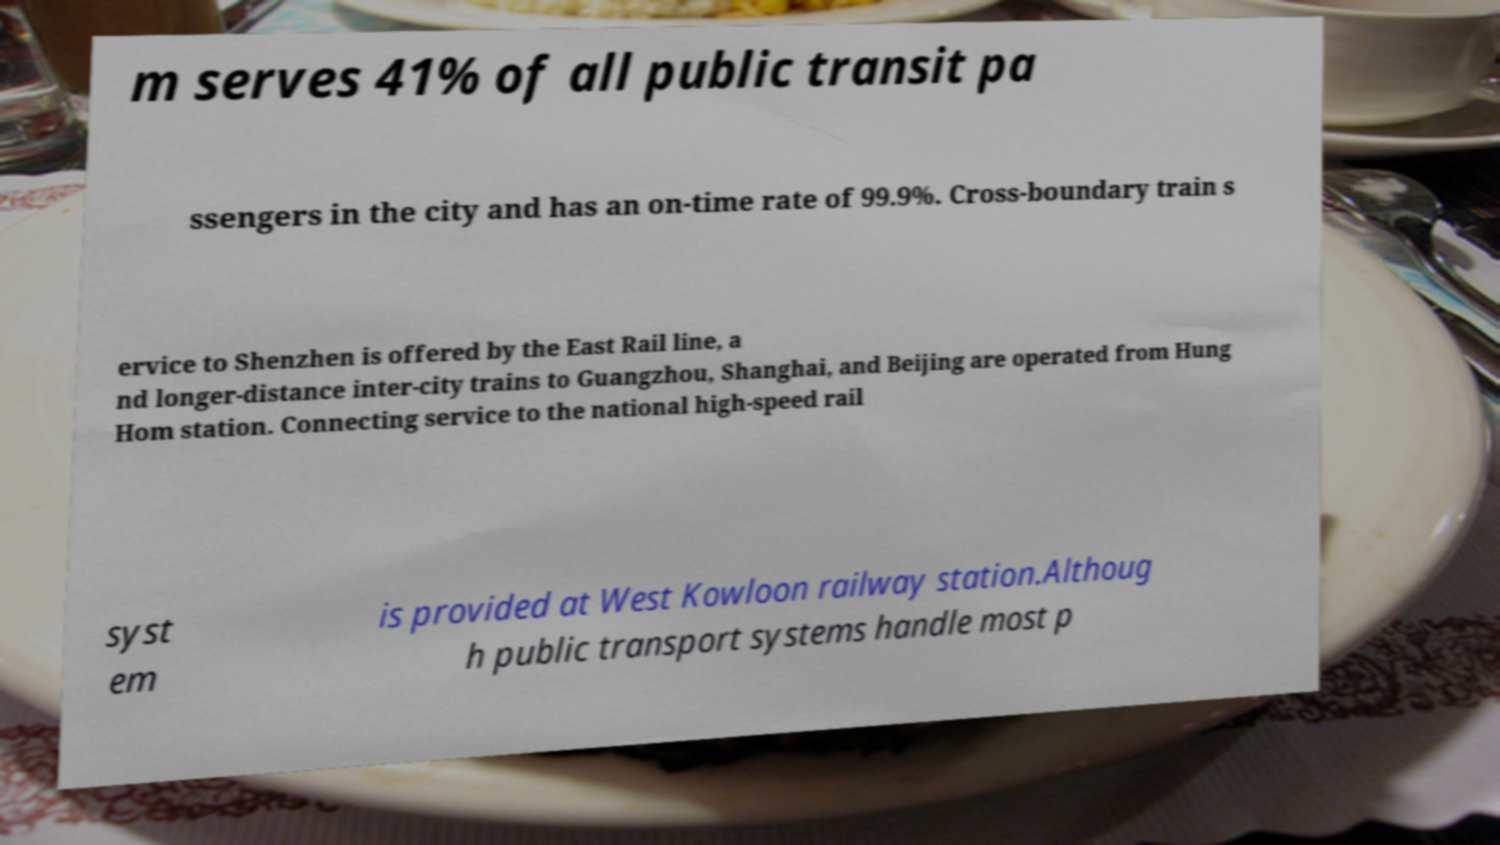For documentation purposes, I need the text within this image transcribed. Could you provide that? m serves 41% of all public transit pa ssengers in the city and has an on-time rate of 99.9%. Cross-boundary train s ervice to Shenzhen is offered by the East Rail line, a nd longer-distance inter-city trains to Guangzhou, Shanghai, and Beijing are operated from Hung Hom station. Connecting service to the national high-speed rail syst em is provided at West Kowloon railway station.Althoug h public transport systems handle most p 